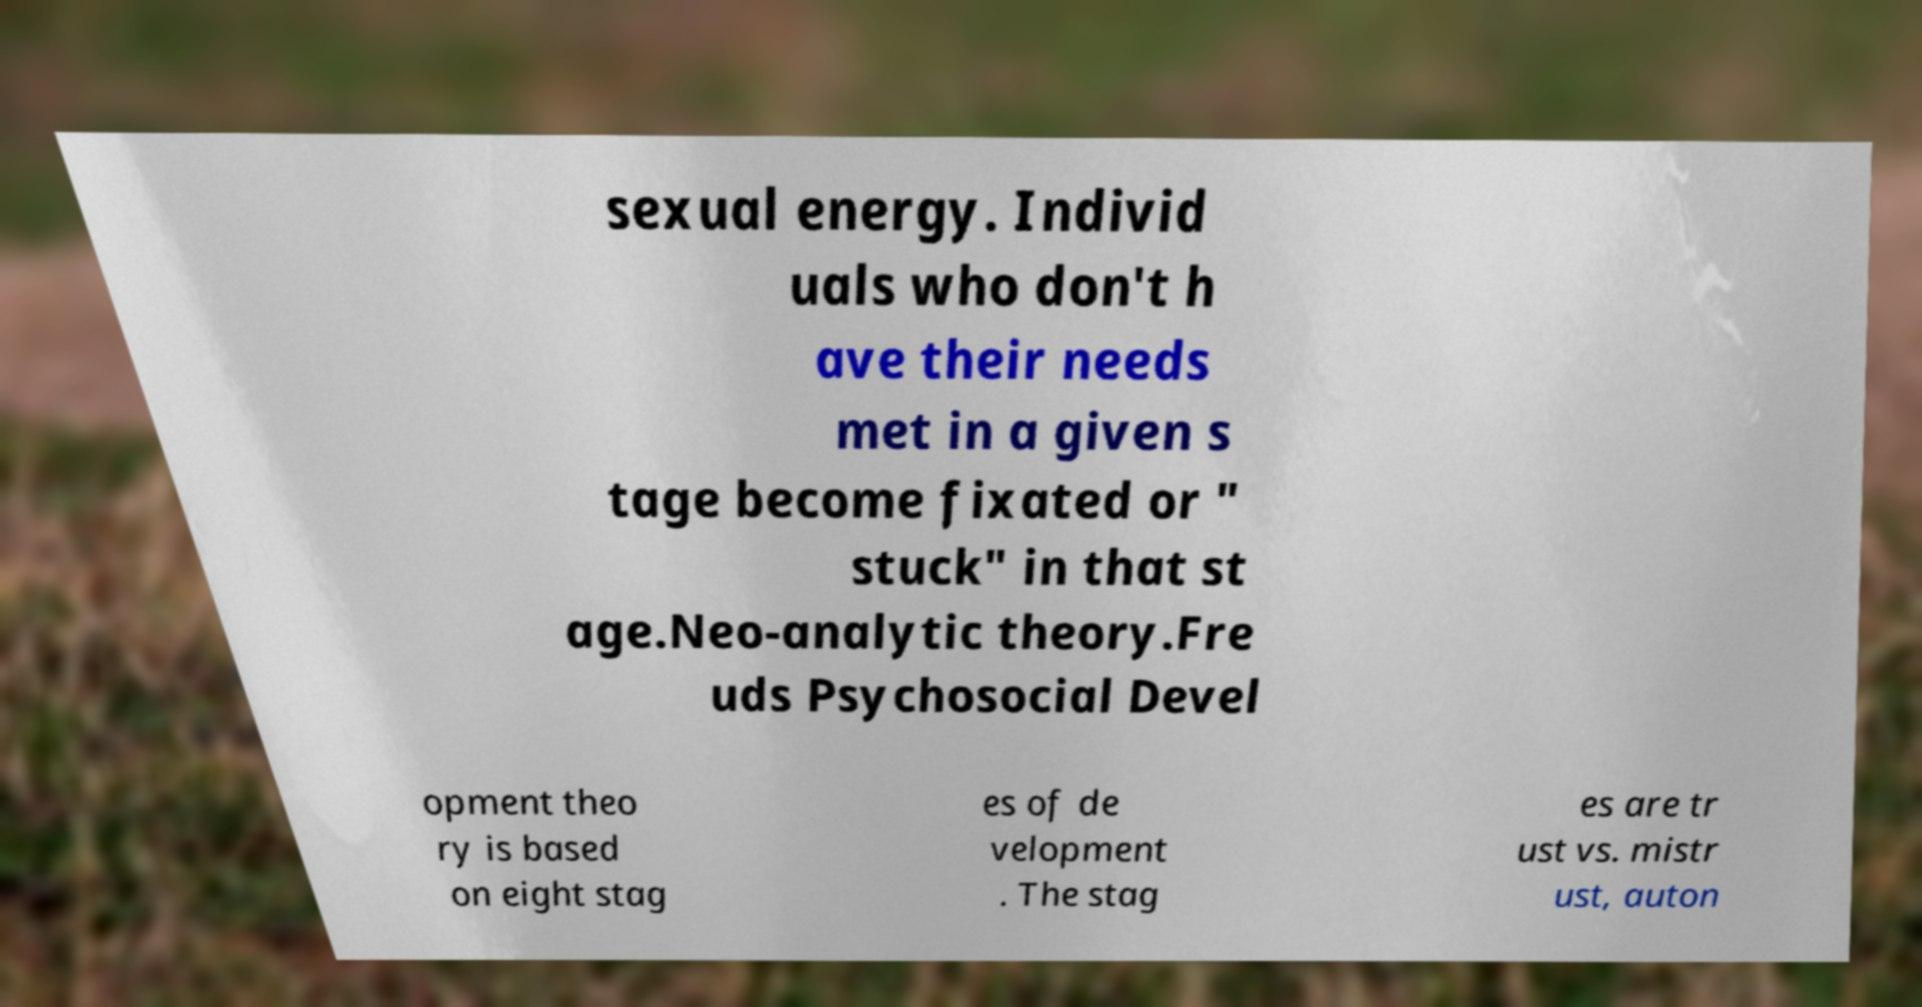Can you accurately transcribe the text from the provided image for me? sexual energy. Individ uals who don't h ave their needs met in a given s tage become fixated or " stuck" in that st age.Neo-analytic theory.Fre uds Psychosocial Devel opment theo ry is based on eight stag es of de velopment . The stag es are tr ust vs. mistr ust, auton 